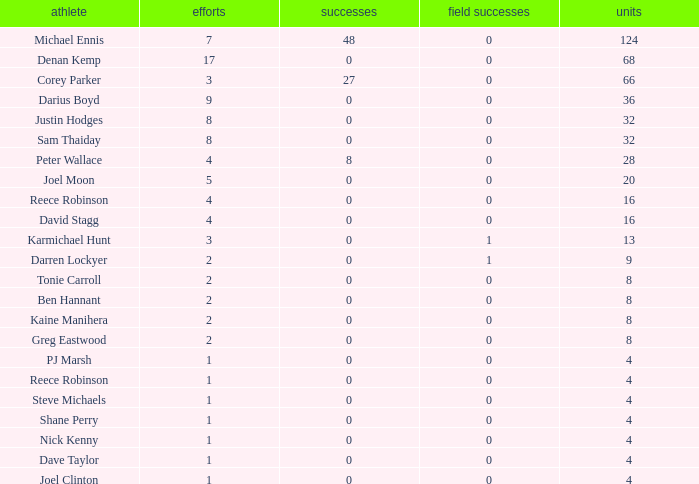What is the total number of field goals of Denan Kemp, who has more than 4 tries, more than 32 points, and 0 goals? 1.0. 